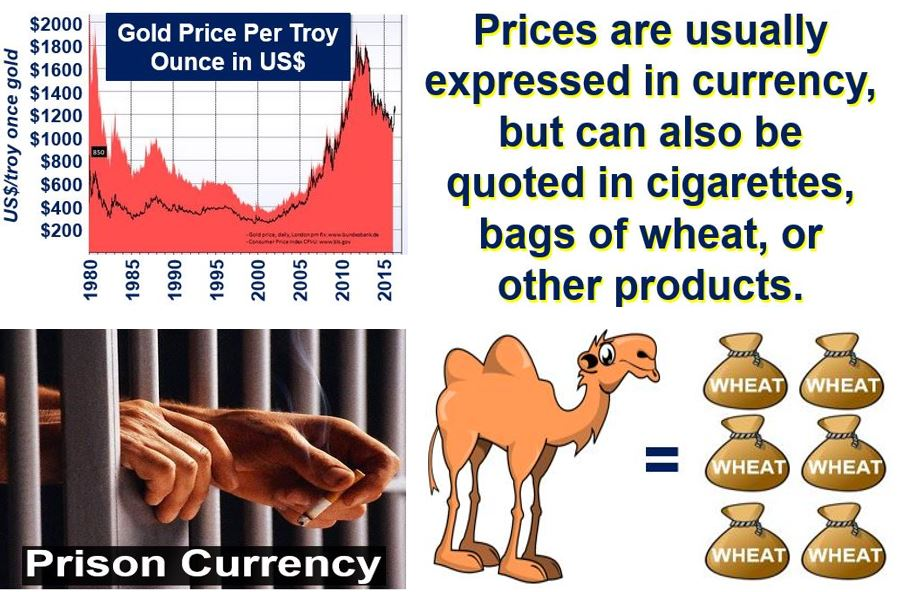Imagine the image represents an alien planet where camel trading is essential. Construct a creative scenario of how wheat might be used and valued in this context. In the alien planet depicted by the image, camels are an essential form of transportation and highly valued. Wheat, on the other hand, is rare and considered a luxury food source. In this alien civilization, wheat may be used not only as a currency but also as a highly prized gift. It has become a symbol of wealth and power due to its nutritional benefits and scarcity. High-ranking officials and noble families trade camels not for traditional currency, but for bags of wheat, which they display to showcase their status. Pilgrimages to the lush, fertile lands where wheat is harvested turn into ceremonial events, attracting traders who hope to exchange camels for valuable wheat, thereby solidifying alliances and social hierarchies. 